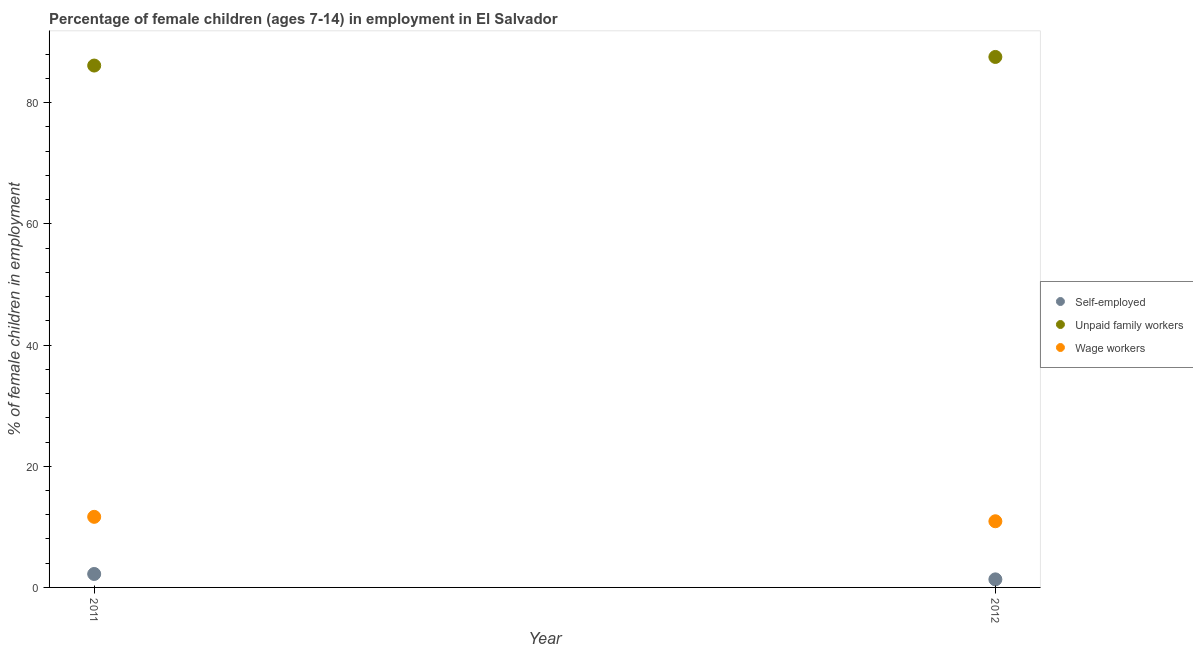How many different coloured dotlines are there?
Keep it short and to the point. 3. Is the number of dotlines equal to the number of legend labels?
Keep it short and to the point. Yes. What is the percentage of children employed as wage workers in 2012?
Keep it short and to the point. 10.92. Across all years, what is the maximum percentage of children employed as wage workers?
Provide a succinct answer. 11.65. Across all years, what is the minimum percentage of children employed as wage workers?
Make the answer very short. 10.92. In which year was the percentage of self employed children maximum?
Your response must be concise. 2011. In which year was the percentage of children employed as unpaid family workers minimum?
Provide a short and direct response. 2011. What is the total percentage of children employed as unpaid family workers in the graph?
Provide a short and direct response. 173.68. What is the difference between the percentage of children employed as unpaid family workers in 2011 and that in 2012?
Give a very brief answer. -1.42. What is the difference between the percentage of self employed children in 2011 and the percentage of children employed as wage workers in 2012?
Your answer should be compact. -8.7. What is the average percentage of children employed as wage workers per year?
Provide a succinct answer. 11.29. In the year 2012, what is the difference between the percentage of children employed as unpaid family workers and percentage of self employed children?
Offer a very short reply. 86.22. In how many years, is the percentage of children employed as unpaid family workers greater than 76 %?
Your answer should be very brief. 2. What is the ratio of the percentage of children employed as unpaid family workers in 2011 to that in 2012?
Offer a very short reply. 0.98. Does the percentage of children employed as unpaid family workers monotonically increase over the years?
Provide a succinct answer. Yes. How many dotlines are there?
Make the answer very short. 3. What is the difference between two consecutive major ticks on the Y-axis?
Ensure brevity in your answer.  20. Are the values on the major ticks of Y-axis written in scientific E-notation?
Keep it short and to the point. No. Does the graph contain any zero values?
Keep it short and to the point. No. What is the title of the graph?
Offer a very short reply. Percentage of female children (ages 7-14) in employment in El Salvador. What is the label or title of the X-axis?
Provide a succinct answer. Year. What is the label or title of the Y-axis?
Your answer should be very brief. % of female children in employment. What is the % of female children in employment in Self-employed in 2011?
Provide a short and direct response. 2.22. What is the % of female children in employment in Unpaid family workers in 2011?
Keep it short and to the point. 86.13. What is the % of female children in employment of Wage workers in 2011?
Your answer should be very brief. 11.65. What is the % of female children in employment of Self-employed in 2012?
Your answer should be compact. 1.33. What is the % of female children in employment of Unpaid family workers in 2012?
Keep it short and to the point. 87.55. What is the % of female children in employment in Wage workers in 2012?
Offer a terse response. 10.92. Across all years, what is the maximum % of female children in employment of Self-employed?
Make the answer very short. 2.22. Across all years, what is the maximum % of female children in employment of Unpaid family workers?
Offer a very short reply. 87.55. Across all years, what is the maximum % of female children in employment of Wage workers?
Your answer should be very brief. 11.65. Across all years, what is the minimum % of female children in employment of Self-employed?
Your answer should be compact. 1.33. Across all years, what is the minimum % of female children in employment in Unpaid family workers?
Give a very brief answer. 86.13. Across all years, what is the minimum % of female children in employment of Wage workers?
Provide a succinct answer. 10.92. What is the total % of female children in employment of Self-employed in the graph?
Provide a short and direct response. 3.55. What is the total % of female children in employment of Unpaid family workers in the graph?
Provide a succinct answer. 173.68. What is the total % of female children in employment in Wage workers in the graph?
Ensure brevity in your answer.  22.57. What is the difference between the % of female children in employment of Self-employed in 2011 and that in 2012?
Offer a terse response. 0.89. What is the difference between the % of female children in employment of Unpaid family workers in 2011 and that in 2012?
Keep it short and to the point. -1.42. What is the difference between the % of female children in employment in Wage workers in 2011 and that in 2012?
Your answer should be compact. 0.73. What is the difference between the % of female children in employment in Self-employed in 2011 and the % of female children in employment in Unpaid family workers in 2012?
Ensure brevity in your answer.  -85.33. What is the difference between the % of female children in employment of Unpaid family workers in 2011 and the % of female children in employment of Wage workers in 2012?
Offer a terse response. 75.21. What is the average % of female children in employment of Self-employed per year?
Keep it short and to the point. 1.77. What is the average % of female children in employment of Unpaid family workers per year?
Your answer should be very brief. 86.84. What is the average % of female children in employment of Wage workers per year?
Your answer should be compact. 11.29. In the year 2011, what is the difference between the % of female children in employment in Self-employed and % of female children in employment in Unpaid family workers?
Offer a very short reply. -83.91. In the year 2011, what is the difference between the % of female children in employment in Self-employed and % of female children in employment in Wage workers?
Provide a succinct answer. -9.43. In the year 2011, what is the difference between the % of female children in employment in Unpaid family workers and % of female children in employment in Wage workers?
Offer a terse response. 74.48. In the year 2012, what is the difference between the % of female children in employment of Self-employed and % of female children in employment of Unpaid family workers?
Give a very brief answer. -86.22. In the year 2012, what is the difference between the % of female children in employment of Self-employed and % of female children in employment of Wage workers?
Your answer should be compact. -9.59. In the year 2012, what is the difference between the % of female children in employment in Unpaid family workers and % of female children in employment in Wage workers?
Your answer should be compact. 76.63. What is the ratio of the % of female children in employment of Self-employed in 2011 to that in 2012?
Your answer should be compact. 1.67. What is the ratio of the % of female children in employment of Unpaid family workers in 2011 to that in 2012?
Provide a short and direct response. 0.98. What is the ratio of the % of female children in employment in Wage workers in 2011 to that in 2012?
Provide a succinct answer. 1.07. What is the difference between the highest and the second highest % of female children in employment of Self-employed?
Your answer should be compact. 0.89. What is the difference between the highest and the second highest % of female children in employment in Unpaid family workers?
Offer a terse response. 1.42. What is the difference between the highest and the second highest % of female children in employment in Wage workers?
Provide a short and direct response. 0.73. What is the difference between the highest and the lowest % of female children in employment of Self-employed?
Provide a succinct answer. 0.89. What is the difference between the highest and the lowest % of female children in employment in Unpaid family workers?
Keep it short and to the point. 1.42. What is the difference between the highest and the lowest % of female children in employment of Wage workers?
Ensure brevity in your answer.  0.73. 